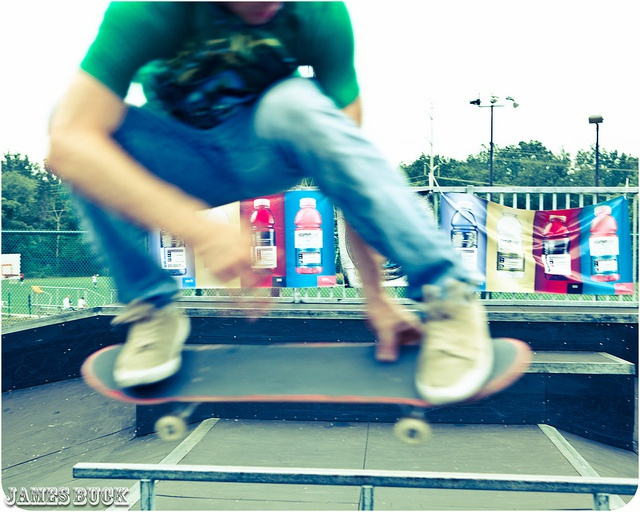Describe the objects in this image and their specific colors. I can see people in white, blue, ivory, khaki, and navy tones, skateboard in white, teal, darkgray, and navy tones, people in white, ivory, lightgreen, darkgray, and turquoise tones, people in white, lightgreen, tan, and beige tones, and people in white, ivory, lightgreen, turquoise, and teal tones in this image. 